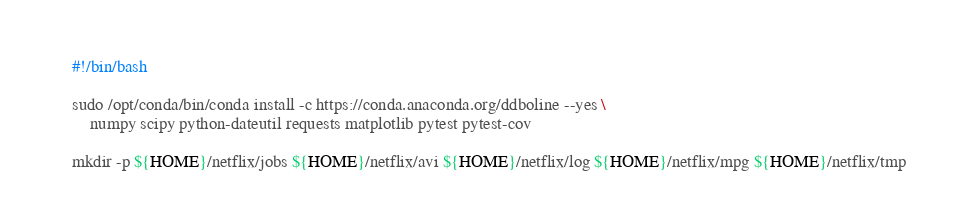Convert code to text. <code><loc_0><loc_0><loc_500><loc_500><_Bash_>#!/bin/bash

sudo /opt/conda/bin/conda install -c https://conda.anaconda.org/ddboline --yes \
    numpy scipy python-dateutil requests matplotlib pytest pytest-cov

mkdir -p ${HOME}/netflix/jobs ${HOME}/netflix/avi ${HOME}/netflix/log ${HOME}/netflix/mpg ${HOME}/netflix/tmp
</code> 